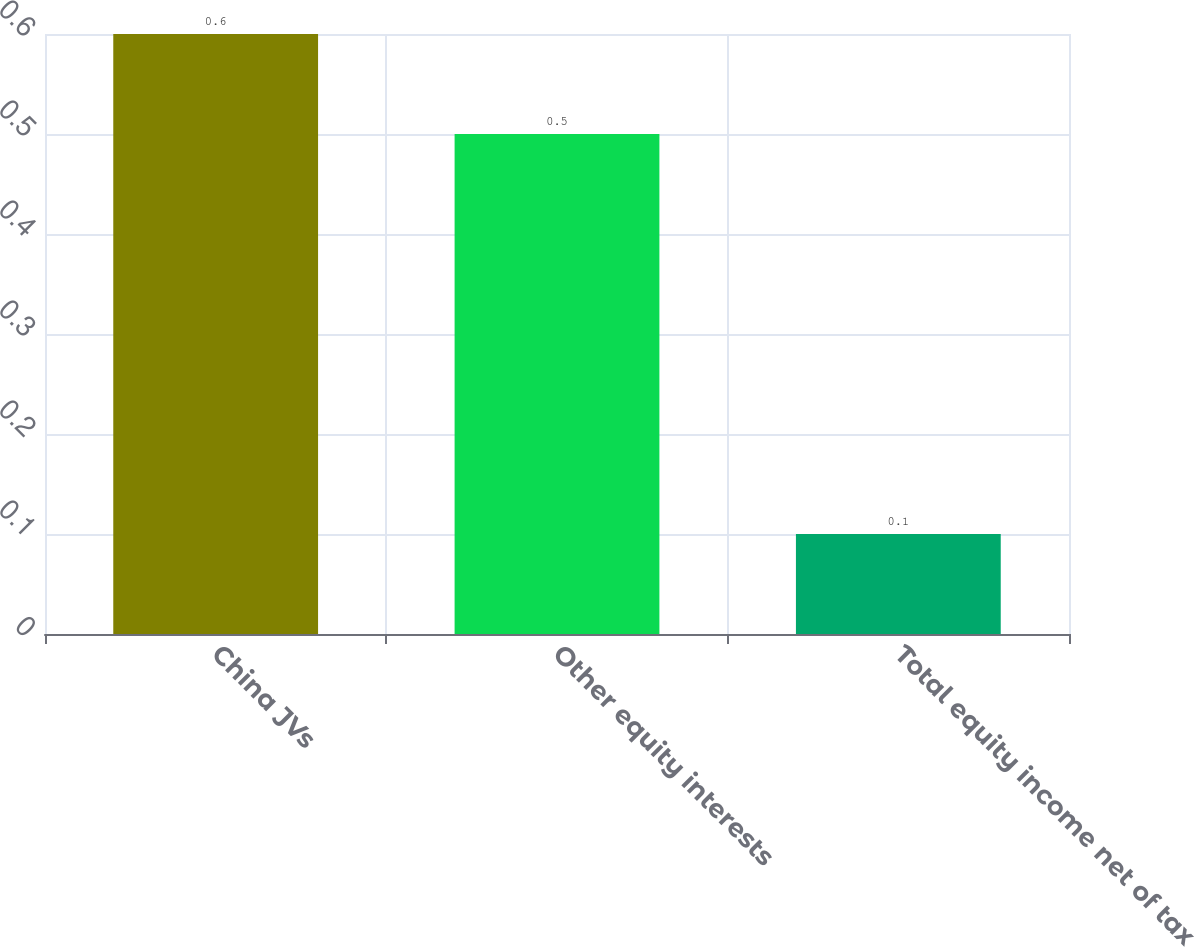Convert chart to OTSL. <chart><loc_0><loc_0><loc_500><loc_500><bar_chart><fcel>China JVs<fcel>Other equity interests<fcel>Total equity income net of tax<nl><fcel>0.6<fcel>0.5<fcel>0.1<nl></chart> 